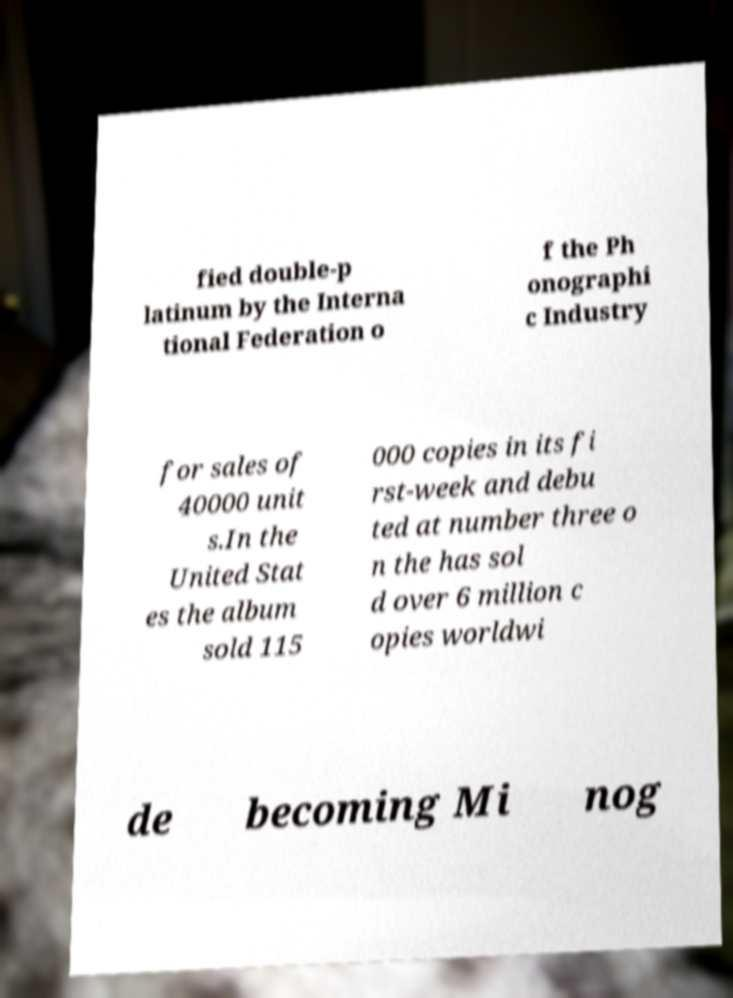For documentation purposes, I need the text within this image transcribed. Could you provide that? fied double-p latinum by the Interna tional Federation o f the Ph onographi c Industry for sales of 40000 unit s.In the United Stat es the album sold 115 000 copies in its fi rst-week and debu ted at number three o n the has sol d over 6 million c opies worldwi de becoming Mi nog 